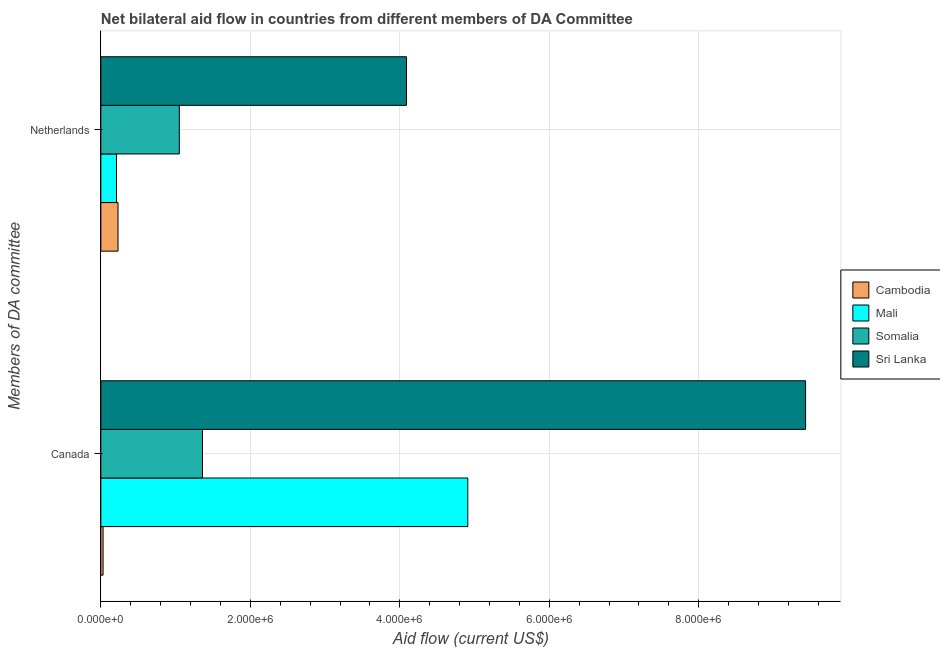How many different coloured bars are there?
Your answer should be very brief. 4. How many bars are there on the 2nd tick from the top?
Your answer should be compact. 4. How many bars are there on the 1st tick from the bottom?
Provide a short and direct response. 4. What is the amount of aid given by canada in Cambodia?
Keep it short and to the point. 3.00e+04. Across all countries, what is the maximum amount of aid given by canada?
Keep it short and to the point. 9.43e+06. Across all countries, what is the minimum amount of aid given by canada?
Provide a short and direct response. 3.00e+04. In which country was the amount of aid given by netherlands maximum?
Make the answer very short. Sri Lanka. In which country was the amount of aid given by netherlands minimum?
Provide a short and direct response. Mali. What is the total amount of aid given by netherlands in the graph?
Your answer should be compact. 5.58e+06. What is the difference between the amount of aid given by canada in Cambodia and that in Somalia?
Provide a succinct answer. -1.33e+06. What is the difference between the amount of aid given by canada in Sri Lanka and the amount of aid given by netherlands in Cambodia?
Offer a very short reply. 9.20e+06. What is the average amount of aid given by canada per country?
Make the answer very short. 3.93e+06. What is the difference between the amount of aid given by netherlands and amount of aid given by canada in Sri Lanka?
Offer a very short reply. -5.34e+06. What is the ratio of the amount of aid given by netherlands in Somalia to that in Mali?
Your answer should be compact. 5. In how many countries, is the amount of aid given by canada greater than the average amount of aid given by canada taken over all countries?
Your answer should be compact. 2. What does the 4th bar from the top in Canada represents?
Give a very brief answer. Cambodia. What does the 3rd bar from the bottom in Netherlands represents?
Provide a succinct answer. Somalia. How many bars are there?
Keep it short and to the point. 8. Are all the bars in the graph horizontal?
Offer a terse response. Yes. Does the graph contain any zero values?
Provide a succinct answer. No. How many legend labels are there?
Make the answer very short. 4. What is the title of the graph?
Ensure brevity in your answer.  Net bilateral aid flow in countries from different members of DA Committee. Does "Europe(developing only)" appear as one of the legend labels in the graph?
Offer a very short reply. No. What is the label or title of the X-axis?
Offer a very short reply. Aid flow (current US$). What is the label or title of the Y-axis?
Provide a succinct answer. Members of DA committee. What is the Aid flow (current US$) of Cambodia in Canada?
Your answer should be compact. 3.00e+04. What is the Aid flow (current US$) in Mali in Canada?
Provide a short and direct response. 4.91e+06. What is the Aid flow (current US$) of Somalia in Canada?
Give a very brief answer. 1.36e+06. What is the Aid flow (current US$) in Sri Lanka in Canada?
Your answer should be very brief. 9.43e+06. What is the Aid flow (current US$) in Cambodia in Netherlands?
Your answer should be very brief. 2.30e+05. What is the Aid flow (current US$) in Somalia in Netherlands?
Give a very brief answer. 1.05e+06. What is the Aid flow (current US$) of Sri Lanka in Netherlands?
Provide a short and direct response. 4.09e+06. Across all Members of DA committee, what is the maximum Aid flow (current US$) in Mali?
Your answer should be compact. 4.91e+06. Across all Members of DA committee, what is the maximum Aid flow (current US$) of Somalia?
Your response must be concise. 1.36e+06. Across all Members of DA committee, what is the maximum Aid flow (current US$) in Sri Lanka?
Offer a terse response. 9.43e+06. Across all Members of DA committee, what is the minimum Aid flow (current US$) in Cambodia?
Provide a short and direct response. 3.00e+04. Across all Members of DA committee, what is the minimum Aid flow (current US$) in Somalia?
Make the answer very short. 1.05e+06. Across all Members of DA committee, what is the minimum Aid flow (current US$) of Sri Lanka?
Your response must be concise. 4.09e+06. What is the total Aid flow (current US$) in Mali in the graph?
Make the answer very short. 5.12e+06. What is the total Aid flow (current US$) in Somalia in the graph?
Give a very brief answer. 2.41e+06. What is the total Aid flow (current US$) in Sri Lanka in the graph?
Keep it short and to the point. 1.35e+07. What is the difference between the Aid flow (current US$) of Cambodia in Canada and that in Netherlands?
Your response must be concise. -2.00e+05. What is the difference between the Aid flow (current US$) in Mali in Canada and that in Netherlands?
Ensure brevity in your answer.  4.70e+06. What is the difference between the Aid flow (current US$) of Sri Lanka in Canada and that in Netherlands?
Make the answer very short. 5.34e+06. What is the difference between the Aid flow (current US$) in Cambodia in Canada and the Aid flow (current US$) in Mali in Netherlands?
Your response must be concise. -1.80e+05. What is the difference between the Aid flow (current US$) in Cambodia in Canada and the Aid flow (current US$) in Somalia in Netherlands?
Offer a terse response. -1.02e+06. What is the difference between the Aid flow (current US$) of Cambodia in Canada and the Aid flow (current US$) of Sri Lanka in Netherlands?
Provide a short and direct response. -4.06e+06. What is the difference between the Aid flow (current US$) in Mali in Canada and the Aid flow (current US$) in Somalia in Netherlands?
Offer a very short reply. 3.86e+06. What is the difference between the Aid flow (current US$) of Mali in Canada and the Aid flow (current US$) of Sri Lanka in Netherlands?
Your response must be concise. 8.20e+05. What is the difference between the Aid flow (current US$) in Somalia in Canada and the Aid flow (current US$) in Sri Lanka in Netherlands?
Ensure brevity in your answer.  -2.73e+06. What is the average Aid flow (current US$) in Mali per Members of DA committee?
Offer a terse response. 2.56e+06. What is the average Aid flow (current US$) of Somalia per Members of DA committee?
Make the answer very short. 1.20e+06. What is the average Aid flow (current US$) of Sri Lanka per Members of DA committee?
Keep it short and to the point. 6.76e+06. What is the difference between the Aid flow (current US$) in Cambodia and Aid flow (current US$) in Mali in Canada?
Give a very brief answer. -4.88e+06. What is the difference between the Aid flow (current US$) of Cambodia and Aid flow (current US$) of Somalia in Canada?
Give a very brief answer. -1.33e+06. What is the difference between the Aid flow (current US$) of Cambodia and Aid flow (current US$) of Sri Lanka in Canada?
Offer a very short reply. -9.40e+06. What is the difference between the Aid flow (current US$) of Mali and Aid flow (current US$) of Somalia in Canada?
Offer a very short reply. 3.55e+06. What is the difference between the Aid flow (current US$) of Mali and Aid flow (current US$) of Sri Lanka in Canada?
Keep it short and to the point. -4.52e+06. What is the difference between the Aid flow (current US$) of Somalia and Aid flow (current US$) of Sri Lanka in Canada?
Provide a succinct answer. -8.07e+06. What is the difference between the Aid flow (current US$) in Cambodia and Aid flow (current US$) in Mali in Netherlands?
Make the answer very short. 2.00e+04. What is the difference between the Aid flow (current US$) in Cambodia and Aid flow (current US$) in Somalia in Netherlands?
Your answer should be compact. -8.20e+05. What is the difference between the Aid flow (current US$) of Cambodia and Aid flow (current US$) of Sri Lanka in Netherlands?
Your answer should be compact. -3.86e+06. What is the difference between the Aid flow (current US$) of Mali and Aid flow (current US$) of Somalia in Netherlands?
Your response must be concise. -8.40e+05. What is the difference between the Aid flow (current US$) in Mali and Aid flow (current US$) in Sri Lanka in Netherlands?
Your answer should be compact. -3.88e+06. What is the difference between the Aid flow (current US$) of Somalia and Aid flow (current US$) of Sri Lanka in Netherlands?
Keep it short and to the point. -3.04e+06. What is the ratio of the Aid flow (current US$) of Cambodia in Canada to that in Netherlands?
Your response must be concise. 0.13. What is the ratio of the Aid flow (current US$) in Mali in Canada to that in Netherlands?
Provide a succinct answer. 23.38. What is the ratio of the Aid flow (current US$) of Somalia in Canada to that in Netherlands?
Offer a terse response. 1.3. What is the ratio of the Aid flow (current US$) in Sri Lanka in Canada to that in Netherlands?
Your response must be concise. 2.31. What is the difference between the highest and the second highest Aid flow (current US$) of Cambodia?
Your answer should be very brief. 2.00e+05. What is the difference between the highest and the second highest Aid flow (current US$) in Mali?
Your answer should be compact. 4.70e+06. What is the difference between the highest and the second highest Aid flow (current US$) in Sri Lanka?
Ensure brevity in your answer.  5.34e+06. What is the difference between the highest and the lowest Aid flow (current US$) of Mali?
Provide a short and direct response. 4.70e+06. What is the difference between the highest and the lowest Aid flow (current US$) of Sri Lanka?
Keep it short and to the point. 5.34e+06. 